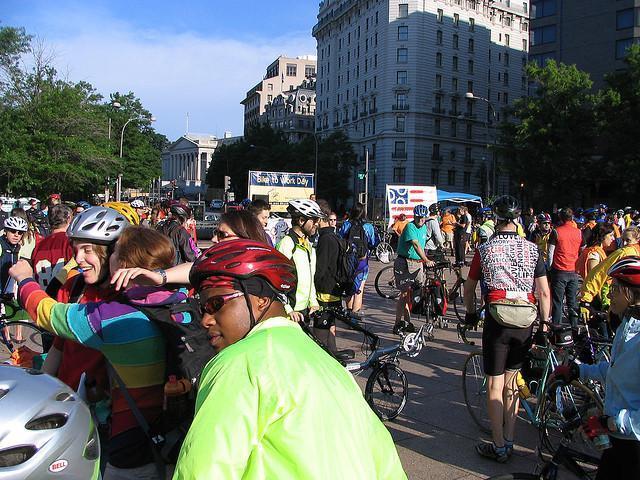How many bicycles are there?
Give a very brief answer. 3. How many backpacks are visible?
Give a very brief answer. 1. How many people can you see?
Give a very brief answer. 8. How many birds are there?
Give a very brief answer. 0. 